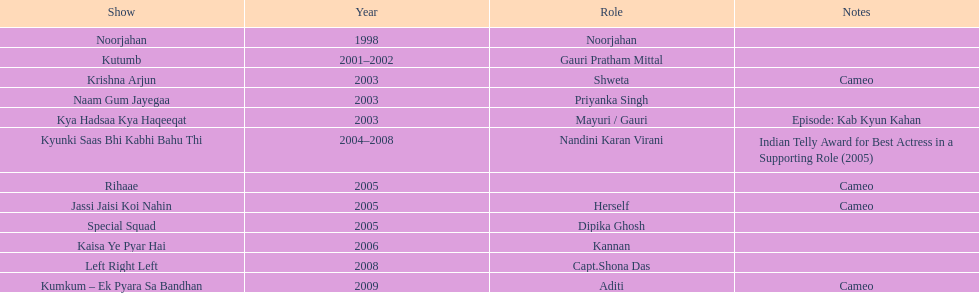The show above left right left Kaisa Ye Pyar Hai. 